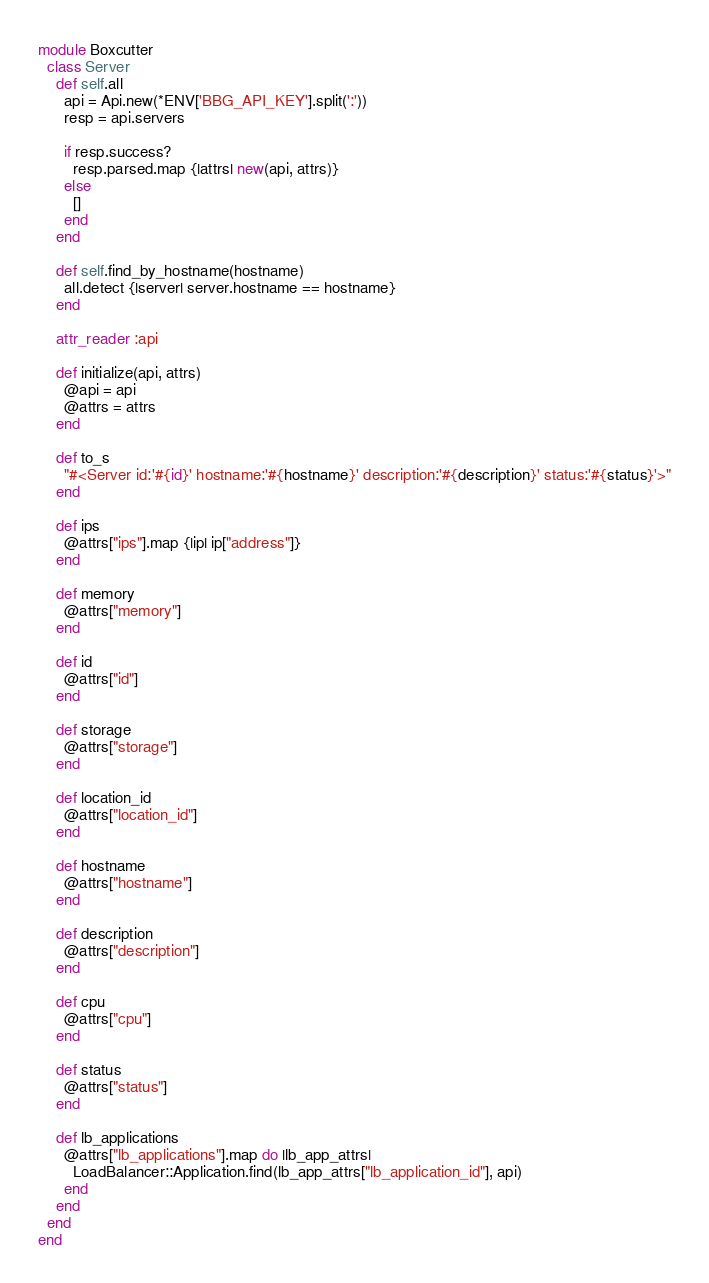<code> <loc_0><loc_0><loc_500><loc_500><_Ruby_>module Boxcutter
  class Server
    def self.all
      api = Api.new(*ENV['BBG_API_KEY'].split(':'))
      resp = api.servers

      if resp.success?
        resp.parsed.map {|attrs| new(api, attrs)}
      else
        []
      end
    end

    def self.find_by_hostname(hostname)
      all.detect {|server| server.hostname == hostname}
    end

    attr_reader :api

    def initialize(api, attrs)
      @api = api
      @attrs = attrs
    end

    def to_s
      "#<Server id:'#{id}' hostname:'#{hostname}' description:'#{description}' status:'#{status}'>"
    end

    def ips
      @attrs["ips"].map {|ip| ip["address"]}
    end

    def memory
      @attrs["memory"]
    end

    def id
      @attrs["id"]
    end

    def storage
      @attrs["storage"]
    end

    def location_id
      @attrs["location_id"]
    end

    def hostname
      @attrs["hostname"]
    end

    def description
      @attrs["description"]
    end

    def cpu
      @attrs["cpu"]
    end

    def status
      @attrs["status"]
    end

    def lb_applications
      @attrs["lb_applications"].map do |lb_app_attrs|
        LoadBalancer::Application.find(lb_app_attrs["lb_application_id"], api)
      end
    end
  end
end
</code> 